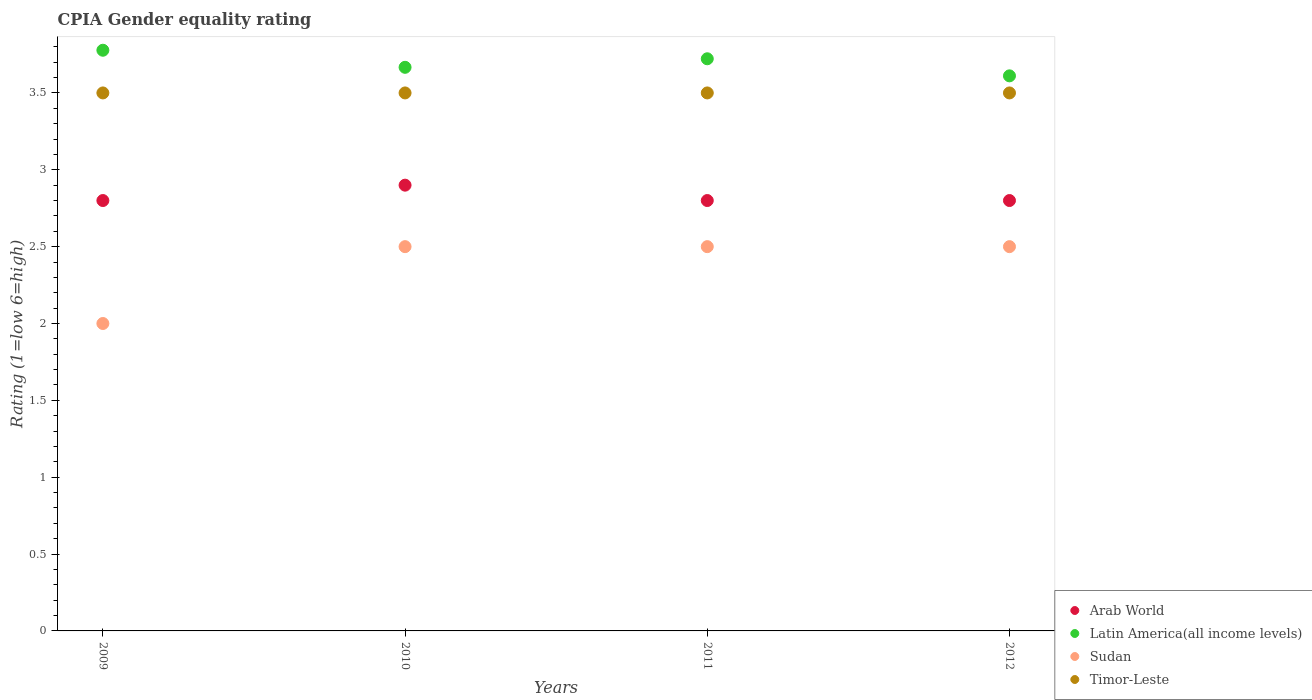Is the number of dotlines equal to the number of legend labels?
Provide a succinct answer. Yes. What is the CPIA rating in Sudan in 2011?
Give a very brief answer. 2.5. In which year was the CPIA rating in Latin America(all income levels) minimum?
Keep it short and to the point. 2012. What is the difference between the CPIA rating in Latin America(all income levels) in 2011 and that in 2012?
Give a very brief answer. 0.11. What is the difference between the CPIA rating in Latin America(all income levels) in 2009 and the CPIA rating in Timor-Leste in 2010?
Your response must be concise. 0.28. What is the average CPIA rating in Timor-Leste per year?
Your answer should be very brief. 3.5. In the year 2009, what is the difference between the CPIA rating in Latin America(all income levels) and CPIA rating in Arab World?
Offer a very short reply. 0.98. What is the ratio of the CPIA rating in Arab World in 2010 to that in 2012?
Your response must be concise. 1.04. How many dotlines are there?
Offer a very short reply. 4. How many legend labels are there?
Your answer should be compact. 4. How are the legend labels stacked?
Offer a very short reply. Vertical. What is the title of the graph?
Provide a succinct answer. CPIA Gender equality rating. Does "Equatorial Guinea" appear as one of the legend labels in the graph?
Offer a terse response. No. What is the label or title of the X-axis?
Provide a short and direct response. Years. What is the label or title of the Y-axis?
Your answer should be very brief. Rating (1=low 6=high). What is the Rating (1=low 6=high) of Arab World in 2009?
Offer a terse response. 2.8. What is the Rating (1=low 6=high) of Latin America(all income levels) in 2009?
Your answer should be compact. 3.78. What is the Rating (1=low 6=high) of Sudan in 2009?
Give a very brief answer. 2. What is the Rating (1=low 6=high) of Timor-Leste in 2009?
Ensure brevity in your answer.  3.5. What is the Rating (1=low 6=high) of Arab World in 2010?
Give a very brief answer. 2.9. What is the Rating (1=low 6=high) in Latin America(all income levels) in 2010?
Offer a very short reply. 3.67. What is the Rating (1=low 6=high) in Sudan in 2010?
Offer a terse response. 2.5. What is the Rating (1=low 6=high) of Timor-Leste in 2010?
Make the answer very short. 3.5. What is the Rating (1=low 6=high) of Arab World in 2011?
Your answer should be compact. 2.8. What is the Rating (1=low 6=high) in Latin America(all income levels) in 2011?
Provide a short and direct response. 3.72. What is the Rating (1=low 6=high) of Timor-Leste in 2011?
Your response must be concise. 3.5. What is the Rating (1=low 6=high) of Arab World in 2012?
Provide a succinct answer. 2.8. What is the Rating (1=low 6=high) of Latin America(all income levels) in 2012?
Offer a very short reply. 3.61. Across all years, what is the maximum Rating (1=low 6=high) in Arab World?
Keep it short and to the point. 2.9. Across all years, what is the maximum Rating (1=low 6=high) in Latin America(all income levels)?
Your response must be concise. 3.78. Across all years, what is the maximum Rating (1=low 6=high) in Timor-Leste?
Offer a terse response. 3.5. Across all years, what is the minimum Rating (1=low 6=high) in Latin America(all income levels)?
Make the answer very short. 3.61. What is the total Rating (1=low 6=high) in Latin America(all income levels) in the graph?
Your answer should be very brief. 14.78. What is the total Rating (1=low 6=high) of Timor-Leste in the graph?
Keep it short and to the point. 14. What is the difference between the Rating (1=low 6=high) in Sudan in 2009 and that in 2010?
Ensure brevity in your answer.  -0.5. What is the difference between the Rating (1=low 6=high) in Timor-Leste in 2009 and that in 2010?
Provide a succinct answer. 0. What is the difference between the Rating (1=low 6=high) of Arab World in 2009 and that in 2011?
Give a very brief answer. 0. What is the difference between the Rating (1=low 6=high) of Latin America(all income levels) in 2009 and that in 2011?
Provide a succinct answer. 0.06. What is the difference between the Rating (1=low 6=high) in Sudan in 2009 and that in 2011?
Provide a short and direct response. -0.5. What is the difference between the Rating (1=low 6=high) of Arab World in 2009 and that in 2012?
Provide a short and direct response. 0. What is the difference between the Rating (1=low 6=high) in Sudan in 2009 and that in 2012?
Offer a very short reply. -0.5. What is the difference between the Rating (1=low 6=high) of Timor-Leste in 2009 and that in 2012?
Give a very brief answer. 0. What is the difference between the Rating (1=low 6=high) of Latin America(all income levels) in 2010 and that in 2011?
Provide a succinct answer. -0.06. What is the difference between the Rating (1=low 6=high) in Arab World in 2010 and that in 2012?
Provide a short and direct response. 0.1. What is the difference between the Rating (1=low 6=high) of Latin America(all income levels) in 2010 and that in 2012?
Your answer should be compact. 0.06. What is the difference between the Rating (1=low 6=high) of Arab World in 2009 and the Rating (1=low 6=high) of Latin America(all income levels) in 2010?
Make the answer very short. -0.87. What is the difference between the Rating (1=low 6=high) of Arab World in 2009 and the Rating (1=low 6=high) of Timor-Leste in 2010?
Ensure brevity in your answer.  -0.7. What is the difference between the Rating (1=low 6=high) in Latin America(all income levels) in 2009 and the Rating (1=low 6=high) in Sudan in 2010?
Offer a very short reply. 1.28. What is the difference between the Rating (1=low 6=high) in Latin America(all income levels) in 2009 and the Rating (1=low 6=high) in Timor-Leste in 2010?
Provide a succinct answer. 0.28. What is the difference between the Rating (1=low 6=high) of Sudan in 2009 and the Rating (1=low 6=high) of Timor-Leste in 2010?
Provide a succinct answer. -1.5. What is the difference between the Rating (1=low 6=high) in Arab World in 2009 and the Rating (1=low 6=high) in Latin America(all income levels) in 2011?
Your answer should be compact. -0.92. What is the difference between the Rating (1=low 6=high) in Latin America(all income levels) in 2009 and the Rating (1=low 6=high) in Sudan in 2011?
Offer a terse response. 1.28. What is the difference between the Rating (1=low 6=high) of Latin America(all income levels) in 2009 and the Rating (1=low 6=high) of Timor-Leste in 2011?
Provide a succinct answer. 0.28. What is the difference between the Rating (1=low 6=high) of Sudan in 2009 and the Rating (1=low 6=high) of Timor-Leste in 2011?
Your answer should be very brief. -1.5. What is the difference between the Rating (1=low 6=high) of Arab World in 2009 and the Rating (1=low 6=high) of Latin America(all income levels) in 2012?
Your response must be concise. -0.81. What is the difference between the Rating (1=low 6=high) in Arab World in 2009 and the Rating (1=low 6=high) in Timor-Leste in 2012?
Give a very brief answer. -0.7. What is the difference between the Rating (1=low 6=high) in Latin America(all income levels) in 2009 and the Rating (1=low 6=high) in Sudan in 2012?
Keep it short and to the point. 1.28. What is the difference between the Rating (1=low 6=high) in Latin America(all income levels) in 2009 and the Rating (1=low 6=high) in Timor-Leste in 2012?
Ensure brevity in your answer.  0.28. What is the difference between the Rating (1=low 6=high) of Arab World in 2010 and the Rating (1=low 6=high) of Latin America(all income levels) in 2011?
Offer a terse response. -0.82. What is the difference between the Rating (1=low 6=high) of Arab World in 2010 and the Rating (1=low 6=high) of Sudan in 2011?
Make the answer very short. 0.4. What is the difference between the Rating (1=low 6=high) of Arab World in 2010 and the Rating (1=low 6=high) of Timor-Leste in 2011?
Offer a terse response. -0.6. What is the difference between the Rating (1=low 6=high) of Latin America(all income levels) in 2010 and the Rating (1=low 6=high) of Sudan in 2011?
Your answer should be very brief. 1.17. What is the difference between the Rating (1=low 6=high) in Sudan in 2010 and the Rating (1=low 6=high) in Timor-Leste in 2011?
Your response must be concise. -1. What is the difference between the Rating (1=low 6=high) of Arab World in 2010 and the Rating (1=low 6=high) of Latin America(all income levels) in 2012?
Ensure brevity in your answer.  -0.71. What is the difference between the Rating (1=low 6=high) of Latin America(all income levels) in 2010 and the Rating (1=low 6=high) of Timor-Leste in 2012?
Keep it short and to the point. 0.17. What is the difference between the Rating (1=low 6=high) in Arab World in 2011 and the Rating (1=low 6=high) in Latin America(all income levels) in 2012?
Make the answer very short. -0.81. What is the difference between the Rating (1=low 6=high) in Arab World in 2011 and the Rating (1=low 6=high) in Sudan in 2012?
Ensure brevity in your answer.  0.3. What is the difference between the Rating (1=low 6=high) of Latin America(all income levels) in 2011 and the Rating (1=low 6=high) of Sudan in 2012?
Provide a short and direct response. 1.22. What is the difference between the Rating (1=low 6=high) of Latin America(all income levels) in 2011 and the Rating (1=low 6=high) of Timor-Leste in 2012?
Your answer should be very brief. 0.22. What is the average Rating (1=low 6=high) of Arab World per year?
Make the answer very short. 2.83. What is the average Rating (1=low 6=high) in Latin America(all income levels) per year?
Provide a succinct answer. 3.69. What is the average Rating (1=low 6=high) of Sudan per year?
Make the answer very short. 2.38. In the year 2009, what is the difference between the Rating (1=low 6=high) of Arab World and Rating (1=low 6=high) of Latin America(all income levels)?
Make the answer very short. -0.98. In the year 2009, what is the difference between the Rating (1=low 6=high) of Latin America(all income levels) and Rating (1=low 6=high) of Sudan?
Offer a very short reply. 1.78. In the year 2009, what is the difference between the Rating (1=low 6=high) in Latin America(all income levels) and Rating (1=low 6=high) in Timor-Leste?
Your response must be concise. 0.28. In the year 2009, what is the difference between the Rating (1=low 6=high) in Sudan and Rating (1=low 6=high) in Timor-Leste?
Provide a succinct answer. -1.5. In the year 2010, what is the difference between the Rating (1=low 6=high) in Arab World and Rating (1=low 6=high) in Latin America(all income levels)?
Your response must be concise. -0.77. In the year 2010, what is the difference between the Rating (1=low 6=high) of Arab World and Rating (1=low 6=high) of Sudan?
Your response must be concise. 0.4. In the year 2010, what is the difference between the Rating (1=low 6=high) in Arab World and Rating (1=low 6=high) in Timor-Leste?
Provide a succinct answer. -0.6. In the year 2010, what is the difference between the Rating (1=low 6=high) of Latin America(all income levels) and Rating (1=low 6=high) of Sudan?
Make the answer very short. 1.17. In the year 2011, what is the difference between the Rating (1=low 6=high) of Arab World and Rating (1=low 6=high) of Latin America(all income levels)?
Offer a very short reply. -0.92. In the year 2011, what is the difference between the Rating (1=low 6=high) in Arab World and Rating (1=low 6=high) in Timor-Leste?
Provide a succinct answer. -0.7. In the year 2011, what is the difference between the Rating (1=low 6=high) of Latin America(all income levels) and Rating (1=low 6=high) of Sudan?
Make the answer very short. 1.22. In the year 2011, what is the difference between the Rating (1=low 6=high) of Latin America(all income levels) and Rating (1=low 6=high) of Timor-Leste?
Your answer should be very brief. 0.22. In the year 2012, what is the difference between the Rating (1=low 6=high) of Arab World and Rating (1=low 6=high) of Latin America(all income levels)?
Ensure brevity in your answer.  -0.81. In the year 2012, what is the difference between the Rating (1=low 6=high) of Latin America(all income levels) and Rating (1=low 6=high) of Sudan?
Provide a short and direct response. 1.11. In the year 2012, what is the difference between the Rating (1=low 6=high) of Sudan and Rating (1=low 6=high) of Timor-Leste?
Your answer should be compact. -1. What is the ratio of the Rating (1=low 6=high) in Arab World in 2009 to that in 2010?
Offer a very short reply. 0.97. What is the ratio of the Rating (1=low 6=high) in Latin America(all income levels) in 2009 to that in 2010?
Provide a short and direct response. 1.03. What is the ratio of the Rating (1=low 6=high) in Timor-Leste in 2009 to that in 2010?
Your answer should be compact. 1. What is the ratio of the Rating (1=low 6=high) in Arab World in 2009 to that in 2011?
Your answer should be compact. 1. What is the ratio of the Rating (1=low 6=high) of Latin America(all income levels) in 2009 to that in 2011?
Your answer should be very brief. 1.01. What is the ratio of the Rating (1=low 6=high) of Latin America(all income levels) in 2009 to that in 2012?
Your response must be concise. 1.05. What is the ratio of the Rating (1=low 6=high) in Sudan in 2009 to that in 2012?
Your response must be concise. 0.8. What is the ratio of the Rating (1=low 6=high) in Arab World in 2010 to that in 2011?
Offer a terse response. 1.04. What is the ratio of the Rating (1=low 6=high) of Latin America(all income levels) in 2010 to that in 2011?
Ensure brevity in your answer.  0.99. What is the ratio of the Rating (1=low 6=high) in Timor-Leste in 2010 to that in 2011?
Offer a terse response. 1. What is the ratio of the Rating (1=low 6=high) of Arab World in 2010 to that in 2012?
Offer a terse response. 1.04. What is the ratio of the Rating (1=low 6=high) of Latin America(all income levels) in 2010 to that in 2012?
Offer a very short reply. 1.02. What is the ratio of the Rating (1=low 6=high) in Timor-Leste in 2010 to that in 2012?
Offer a very short reply. 1. What is the ratio of the Rating (1=low 6=high) of Latin America(all income levels) in 2011 to that in 2012?
Give a very brief answer. 1.03. What is the ratio of the Rating (1=low 6=high) of Timor-Leste in 2011 to that in 2012?
Your answer should be compact. 1. What is the difference between the highest and the second highest Rating (1=low 6=high) in Latin America(all income levels)?
Provide a short and direct response. 0.06. What is the difference between the highest and the second highest Rating (1=low 6=high) of Sudan?
Your answer should be compact. 0. What is the difference between the highest and the second highest Rating (1=low 6=high) in Timor-Leste?
Offer a very short reply. 0. What is the difference between the highest and the lowest Rating (1=low 6=high) in Sudan?
Keep it short and to the point. 0.5. What is the difference between the highest and the lowest Rating (1=low 6=high) in Timor-Leste?
Your response must be concise. 0. 